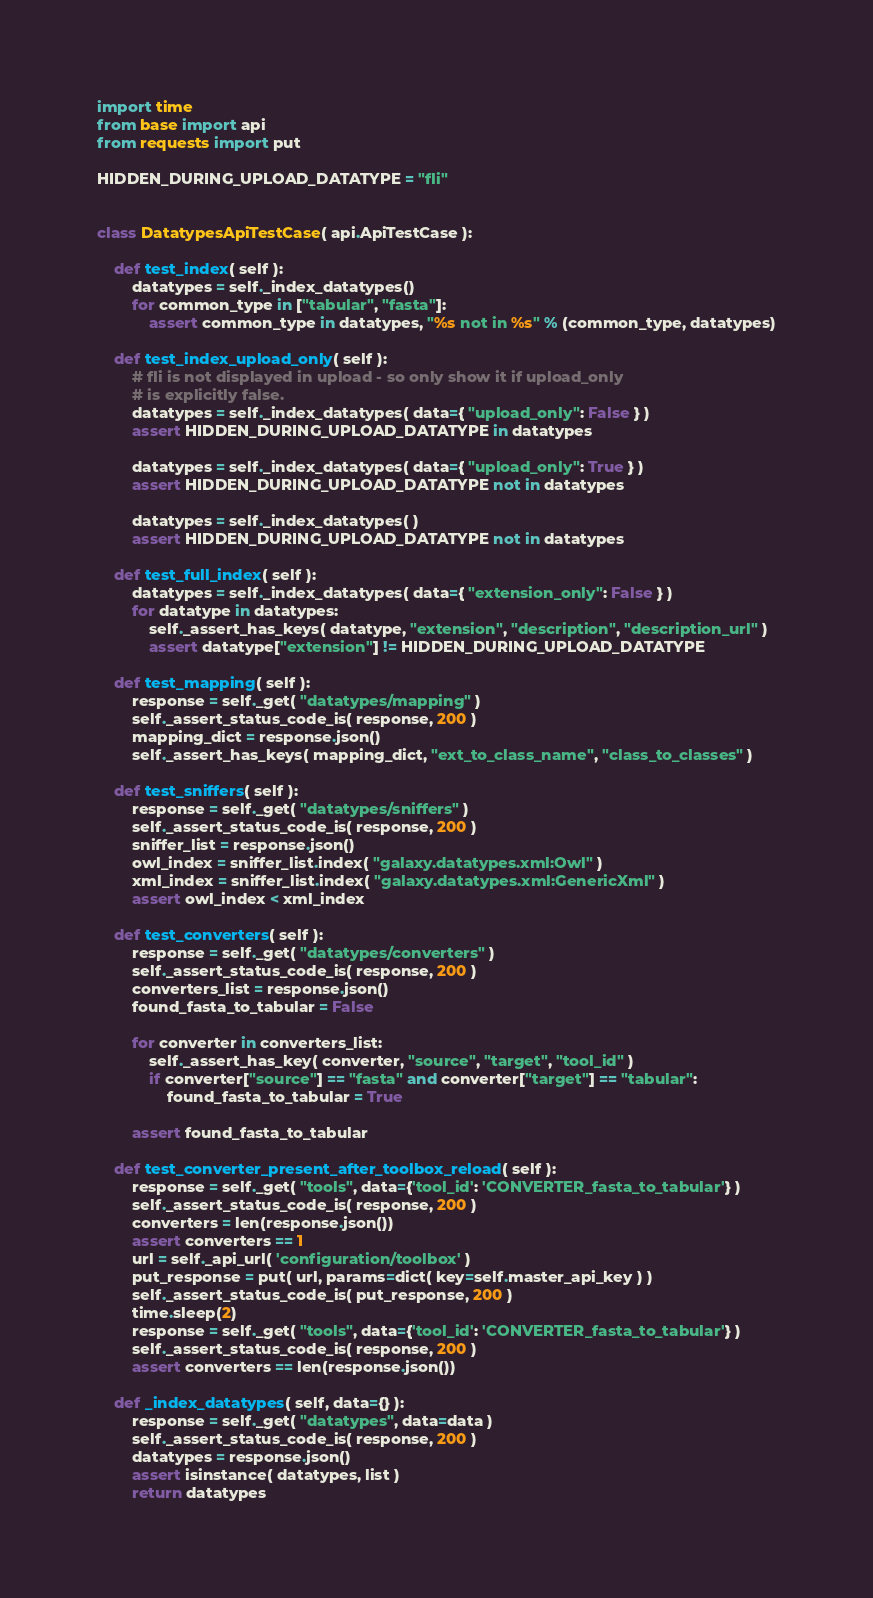Convert code to text. <code><loc_0><loc_0><loc_500><loc_500><_Python_>import time
from base import api
from requests import put

HIDDEN_DURING_UPLOAD_DATATYPE = "fli"


class DatatypesApiTestCase( api.ApiTestCase ):

    def test_index( self ):
        datatypes = self._index_datatypes()
        for common_type in ["tabular", "fasta"]:
            assert common_type in datatypes, "%s not in %s" % (common_type, datatypes)

    def test_index_upload_only( self ):
        # fli is not displayed in upload - so only show it if upload_only
        # is explicitly false.
        datatypes = self._index_datatypes( data={ "upload_only": False } )
        assert HIDDEN_DURING_UPLOAD_DATATYPE in datatypes

        datatypes = self._index_datatypes( data={ "upload_only": True } )
        assert HIDDEN_DURING_UPLOAD_DATATYPE not in datatypes

        datatypes = self._index_datatypes( )
        assert HIDDEN_DURING_UPLOAD_DATATYPE not in datatypes

    def test_full_index( self ):
        datatypes = self._index_datatypes( data={ "extension_only": False } )
        for datatype in datatypes:
            self._assert_has_keys( datatype, "extension", "description", "description_url" )
            assert datatype["extension"] != HIDDEN_DURING_UPLOAD_DATATYPE

    def test_mapping( self ):
        response = self._get( "datatypes/mapping" )
        self._assert_status_code_is( response, 200 )
        mapping_dict = response.json()
        self._assert_has_keys( mapping_dict, "ext_to_class_name", "class_to_classes" )

    def test_sniffers( self ):
        response = self._get( "datatypes/sniffers" )
        self._assert_status_code_is( response, 200 )
        sniffer_list = response.json()
        owl_index = sniffer_list.index( "galaxy.datatypes.xml:Owl" )
        xml_index = sniffer_list.index( "galaxy.datatypes.xml:GenericXml" )
        assert owl_index < xml_index

    def test_converters( self ):
        response = self._get( "datatypes/converters" )
        self._assert_status_code_is( response, 200 )
        converters_list = response.json()
        found_fasta_to_tabular = False

        for converter in converters_list:
            self._assert_has_key( converter, "source", "target", "tool_id" )
            if converter["source"] == "fasta" and converter["target"] == "tabular":
                found_fasta_to_tabular = True

        assert found_fasta_to_tabular

    def test_converter_present_after_toolbox_reload( self ):
        response = self._get( "tools", data={'tool_id': 'CONVERTER_fasta_to_tabular'} )
        self._assert_status_code_is( response, 200 )
        converters = len(response.json())
        assert converters == 1
        url = self._api_url( 'configuration/toolbox' )
        put_response = put( url, params=dict( key=self.master_api_key ) )
        self._assert_status_code_is( put_response, 200 )
        time.sleep(2)
        response = self._get( "tools", data={'tool_id': 'CONVERTER_fasta_to_tabular'} )
        self._assert_status_code_is( response, 200 )
        assert converters == len(response.json())

    def _index_datatypes( self, data={} ):
        response = self._get( "datatypes", data=data )
        self._assert_status_code_is( response, 200 )
        datatypes = response.json()
        assert isinstance( datatypes, list )
        return datatypes
</code> 